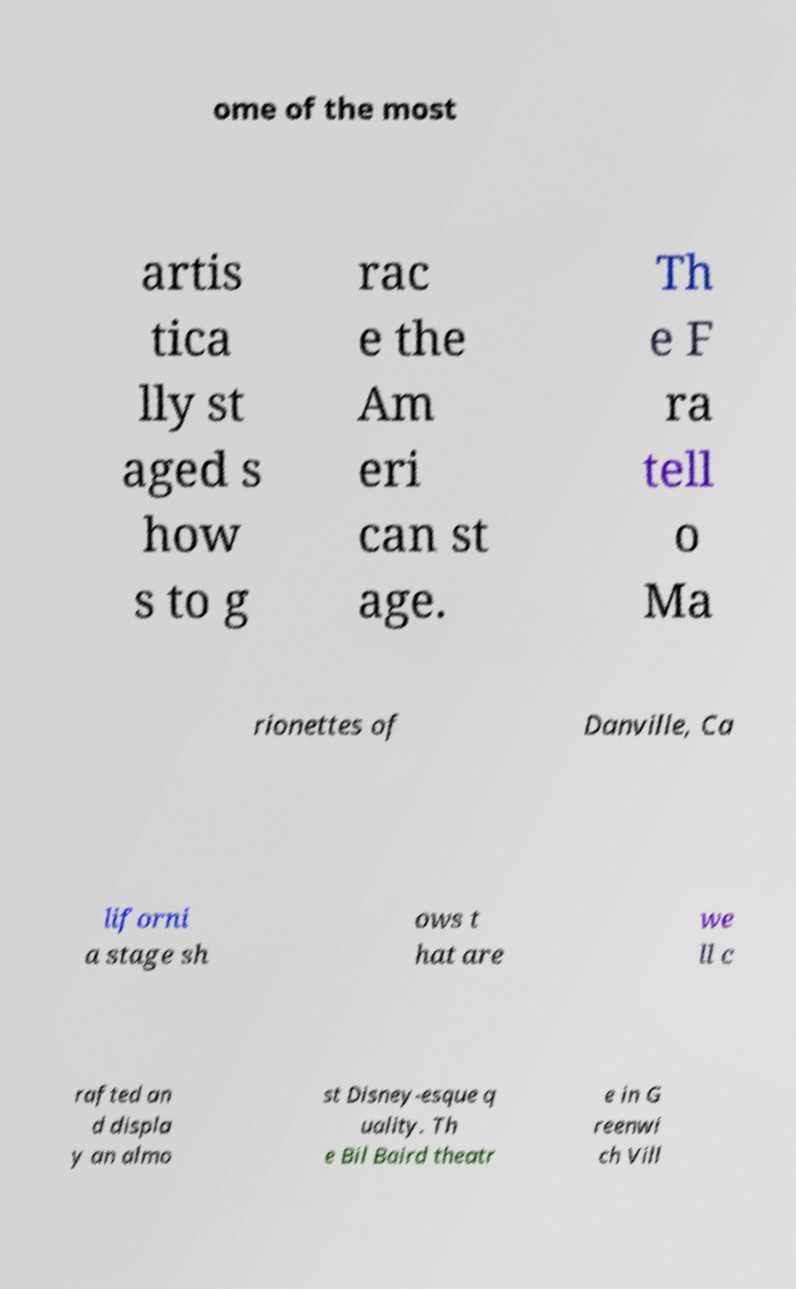Please identify and transcribe the text found in this image. ome of the most artis tica lly st aged s how s to g rac e the Am eri can st age. Th e F ra tell o Ma rionettes of Danville, Ca liforni a stage sh ows t hat are we ll c rafted an d displa y an almo st Disney-esque q uality. Th e Bil Baird theatr e in G reenwi ch Vill 